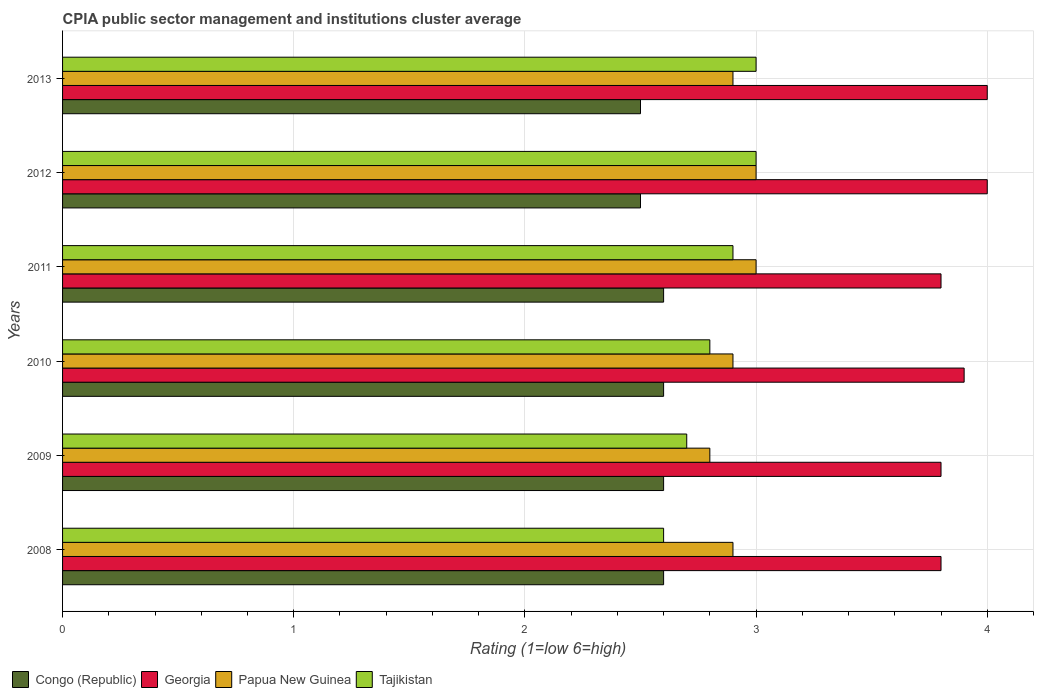How many different coloured bars are there?
Offer a very short reply. 4. How many groups of bars are there?
Your answer should be compact. 6. Are the number of bars per tick equal to the number of legend labels?
Keep it short and to the point. Yes. How many bars are there on the 2nd tick from the bottom?
Offer a very short reply. 4. Across all years, what is the maximum CPIA rating in Tajikistan?
Your response must be concise. 3. Across all years, what is the minimum CPIA rating in Papua New Guinea?
Make the answer very short. 2.8. What is the total CPIA rating in Georgia in the graph?
Your answer should be very brief. 23.3. What is the difference between the CPIA rating in Papua New Guinea in 2008 and that in 2010?
Provide a succinct answer. 0. What is the average CPIA rating in Georgia per year?
Give a very brief answer. 3.88. In how many years, is the CPIA rating in Georgia greater than 0.6000000000000001 ?
Make the answer very short. 6. Is the difference between the CPIA rating in Georgia in 2011 and 2012 greater than the difference between the CPIA rating in Tajikistan in 2011 and 2012?
Ensure brevity in your answer.  No. What is the difference between the highest and the second highest CPIA rating in Papua New Guinea?
Make the answer very short. 0. What is the difference between the highest and the lowest CPIA rating in Georgia?
Provide a short and direct response. 0.2. In how many years, is the CPIA rating in Tajikistan greater than the average CPIA rating in Tajikistan taken over all years?
Provide a succinct answer. 3. Is the sum of the CPIA rating in Congo (Republic) in 2009 and 2011 greater than the maximum CPIA rating in Tajikistan across all years?
Give a very brief answer. Yes. What does the 4th bar from the top in 2009 represents?
Your answer should be compact. Congo (Republic). What does the 4th bar from the bottom in 2012 represents?
Provide a succinct answer. Tajikistan. Is it the case that in every year, the sum of the CPIA rating in Papua New Guinea and CPIA rating in Tajikistan is greater than the CPIA rating in Georgia?
Your answer should be very brief. Yes. How many bars are there?
Keep it short and to the point. 24. Are all the bars in the graph horizontal?
Ensure brevity in your answer.  Yes. How many years are there in the graph?
Keep it short and to the point. 6. What is the difference between two consecutive major ticks on the X-axis?
Offer a terse response. 1. Does the graph contain grids?
Your answer should be compact. Yes. How many legend labels are there?
Provide a succinct answer. 4. How are the legend labels stacked?
Offer a terse response. Horizontal. What is the title of the graph?
Provide a succinct answer. CPIA public sector management and institutions cluster average. Does "Malta" appear as one of the legend labels in the graph?
Your response must be concise. No. What is the label or title of the X-axis?
Offer a terse response. Rating (1=low 6=high). What is the Rating (1=low 6=high) in Congo (Republic) in 2009?
Ensure brevity in your answer.  2.6. What is the Rating (1=low 6=high) in Congo (Republic) in 2010?
Your answer should be very brief. 2.6. What is the Rating (1=low 6=high) in Tajikistan in 2010?
Your answer should be very brief. 2.8. What is the Rating (1=low 6=high) in Congo (Republic) in 2011?
Your answer should be compact. 2.6. What is the Rating (1=low 6=high) of Tajikistan in 2011?
Your response must be concise. 2.9. What is the Rating (1=low 6=high) of Georgia in 2012?
Your response must be concise. 4. What is the Rating (1=low 6=high) of Congo (Republic) in 2013?
Offer a very short reply. 2.5. What is the Rating (1=low 6=high) of Georgia in 2013?
Provide a succinct answer. 4. What is the Rating (1=low 6=high) in Papua New Guinea in 2013?
Offer a terse response. 2.9. Across all years, what is the maximum Rating (1=low 6=high) in Georgia?
Give a very brief answer. 4. Across all years, what is the maximum Rating (1=low 6=high) of Tajikistan?
Your answer should be compact. 3. Across all years, what is the minimum Rating (1=low 6=high) of Georgia?
Offer a very short reply. 3.8. Across all years, what is the minimum Rating (1=low 6=high) of Papua New Guinea?
Ensure brevity in your answer.  2.8. What is the total Rating (1=low 6=high) of Congo (Republic) in the graph?
Offer a terse response. 15.4. What is the total Rating (1=low 6=high) of Georgia in the graph?
Ensure brevity in your answer.  23.3. What is the total Rating (1=low 6=high) in Tajikistan in the graph?
Provide a short and direct response. 17. What is the difference between the Rating (1=low 6=high) of Congo (Republic) in 2008 and that in 2009?
Keep it short and to the point. 0. What is the difference between the Rating (1=low 6=high) in Tajikistan in 2008 and that in 2010?
Make the answer very short. -0.2. What is the difference between the Rating (1=low 6=high) of Georgia in 2008 and that in 2011?
Ensure brevity in your answer.  0. What is the difference between the Rating (1=low 6=high) of Papua New Guinea in 2008 and that in 2011?
Make the answer very short. -0.1. What is the difference between the Rating (1=low 6=high) in Tajikistan in 2008 and that in 2011?
Make the answer very short. -0.3. What is the difference between the Rating (1=low 6=high) in Congo (Republic) in 2008 and that in 2012?
Keep it short and to the point. 0.1. What is the difference between the Rating (1=low 6=high) of Georgia in 2008 and that in 2012?
Provide a succinct answer. -0.2. What is the difference between the Rating (1=low 6=high) in Papua New Guinea in 2008 and that in 2013?
Provide a succinct answer. 0. What is the difference between the Rating (1=low 6=high) of Tajikistan in 2009 and that in 2010?
Provide a short and direct response. -0.1. What is the difference between the Rating (1=low 6=high) of Congo (Republic) in 2009 and that in 2011?
Ensure brevity in your answer.  0. What is the difference between the Rating (1=low 6=high) in Tajikistan in 2009 and that in 2011?
Offer a very short reply. -0.2. What is the difference between the Rating (1=low 6=high) in Congo (Republic) in 2009 and that in 2012?
Your response must be concise. 0.1. What is the difference between the Rating (1=low 6=high) in Georgia in 2009 and that in 2013?
Your answer should be very brief. -0.2. What is the difference between the Rating (1=low 6=high) in Papua New Guinea in 2009 and that in 2013?
Offer a terse response. -0.1. What is the difference between the Rating (1=low 6=high) in Tajikistan in 2010 and that in 2011?
Your response must be concise. -0.1. What is the difference between the Rating (1=low 6=high) in Congo (Republic) in 2010 and that in 2012?
Your answer should be very brief. 0.1. What is the difference between the Rating (1=low 6=high) in Tajikistan in 2010 and that in 2012?
Offer a very short reply. -0.2. What is the difference between the Rating (1=low 6=high) of Congo (Republic) in 2010 and that in 2013?
Make the answer very short. 0.1. What is the difference between the Rating (1=low 6=high) in Georgia in 2010 and that in 2013?
Your response must be concise. -0.1. What is the difference between the Rating (1=low 6=high) in Tajikistan in 2010 and that in 2013?
Provide a short and direct response. -0.2. What is the difference between the Rating (1=low 6=high) in Georgia in 2011 and that in 2012?
Offer a terse response. -0.2. What is the difference between the Rating (1=low 6=high) of Papua New Guinea in 2011 and that in 2012?
Keep it short and to the point. 0. What is the difference between the Rating (1=low 6=high) in Tajikistan in 2011 and that in 2012?
Your answer should be compact. -0.1. What is the difference between the Rating (1=low 6=high) of Congo (Republic) in 2011 and that in 2013?
Make the answer very short. 0.1. What is the difference between the Rating (1=low 6=high) of Congo (Republic) in 2012 and that in 2013?
Your response must be concise. 0. What is the difference between the Rating (1=low 6=high) of Tajikistan in 2012 and that in 2013?
Provide a succinct answer. 0. What is the difference between the Rating (1=low 6=high) in Papua New Guinea in 2008 and the Rating (1=low 6=high) in Tajikistan in 2009?
Offer a very short reply. 0.2. What is the difference between the Rating (1=low 6=high) of Congo (Republic) in 2008 and the Rating (1=low 6=high) of Georgia in 2010?
Your answer should be compact. -1.3. What is the difference between the Rating (1=low 6=high) of Georgia in 2008 and the Rating (1=low 6=high) of Tajikistan in 2010?
Provide a short and direct response. 1. What is the difference between the Rating (1=low 6=high) of Papua New Guinea in 2008 and the Rating (1=low 6=high) of Tajikistan in 2010?
Your response must be concise. 0.1. What is the difference between the Rating (1=low 6=high) in Congo (Republic) in 2008 and the Rating (1=low 6=high) in Georgia in 2011?
Make the answer very short. -1.2. What is the difference between the Rating (1=low 6=high) of Congo (Republic) in 2008 and the Rating (1=low 6=high) of Tajikistan in 2011?
Offer a very short reply. -0.3. What is the difference between the Rating (1=low 6=high) of Georgia in 2008 and the Rating (1=low 6=high) of Papua New Guinea in 2011?
Offer a terse response. 0.8. What is the difference between the Rating (1=low 6=high) of Congo (Republic) in 2008 and the Rating (1=low 6=high) of Papua New Guinea in 2012?
Keep it short and to the point. -0.4. What is the difference between the Rating (1=low 6=high) in Georgia in 2008 and the Rating (1=low 6=high) in Papua New Guinea in 2012?
Your answer should be very brief. 0.8. What is the difference between the Rating (1=low 6=high) in Papua New Guinea in 2008 and the Rating (1=low 6=high) in Tajikistan in 2012?
Your response must be concise. -0.1. What is the difference between the Rating (1=low 6=high) in Congo (Republic) in 2008 and the Rating (1=low 6=high) in Georgia in 2013?
Provide a succinct answer. -1.4. What is the difference between the Rating (1=low 6=high) in Georgia in 2008 and the Rating (1=low 6=high) in Papua New Guinea in 2013?
Provide a succinct answer. 0.9. What is the difference between the Rating (1=low 6=high) in Congo (Republic) in 2009 and the Rating (1=low 6=high) in Georgia in 2010?
Your answer should be very brief. -1.3. What is the difference between the Rating (1=low 6=high) in Georgia in 2009 and the Rating (1=low 6=high) in Papua New Guinea in 2011?
Provide a succinct answer. 0.8. What is the difference between the Rating (1=low 6=high) in Congo (Republic) in 2009 and the Rating (1=low 6=high) in Georgia in 2012?
Your response must be concise. -1.4. What is the difference between the Rating (1=low 6=high) of Congo (Republic) in 2009 and the Rating (1=low 6=high) of Papua New Guinea in 2012?
Provide a short and direct response. -0.4. What is the difference between the Rating (1=low 6=high) in Georgia in 2009 and the Rating (1=low 6=high) in Papua New Guinea in 2012?
Offer a terse response. 0.8. What is the difference between the Rating (1=low 6=high) of Papua New Guinea in 2009 and the Rating (1=low 6=high) of Tajikistan in 2012?
Offer a very short reply. -0.2. What is the difference between the Rating (1=low 6=high) of Congo (Republic) in 2009 and the Rating (1=low 6=high) of Papua New Guinea in 2013?
Keep it short and to the point. -0.3. What is the difference between the Rating (1=low 6=high) of Congo (Republic) in 2009 and the Rating (1=low 6=high) of Tajikistan in 2013?
Ensure brevity in your answer.  -0.4. What is the difference between the Rating (1=low 6=high) in Georgia in 2009 and the Rating (1=low 6=high) in Tajikistan in 2013?
Your response must be concise. 0.8. What is the difference between the Rating (1=low 6=high) in Papua New Guinea in 2009 and the Rating (1=low 6=high) in Tajikistan in 2013?
Your answer should be compact. -0.2. What is the difference between the Rating (1=low 6=high) in Congo (Republic) in 2010 and the Rating (1=low 6=high) in Georgia in 2011?
Your answer should be very brief. -1.2. What is the difference between the Rating (1=low 6=high) of Congo (Republic) in 2010 and the Rating (1=low 6=high) of Papua New Guinea in 2011?
Ensure brevity in your answer.  -0.4. What is the difference between the Rating (1=low 6=high) of Congo (Republic) in 2010 and the Rating (1=low 6=high) of Tajikistan in 2011?
Make the answer very short. -0.3. What is the difference between the Rating (1=low 6=high) in Papua New Guinea in 2010 and the Rating (1=low 6=high) in Tajikistan in 2011?
Provide a short and direct response. 0. What is the difference between the Rating (1=low 6=high) in Papua New Guinea in 2010 and the Rating (1=low 6=high) in Tajikistan in 2012?
Keep it short and to the point. -0.1. What is the difference between the Rating (1=low 6=high) in Congo (Republic) in 2010 and the Rating (1=low 6=high) in Tajikistan in 2013?
Offer a very short reply. -0.4. What is the difference between the Rating (1=low 6=high) of Georgia in 2010 and the Rating (1=low 6=high) of Tajikistan in 2013?
Give a very brief answer. 0.9. What is the difference between the Rating (1=low 6=high) in Papua New Guinea in 2010 and the Rating (1=low 6=high) in Tajikistan in 2013?
Provide a short and direct response. -0.1. What is the difference between the Rating (1=low 6=high) in Congo (Republic) in 2011 and the Rating (1=low 6=high) in Papua New Guinea in 2012?
Ensure brevity in your answer.  -0.4. What is the difference between the Rating (1=low 6=high) in Congo (Republic) in 2011 and the Rating (1=low 6=high) in Tajikistan in 2012?
Provide a short and direct response. -0.4. What is the difference between the Rating (1=low 6=high) of Georgia in 2011 and the Rating (1=low 6=high) of Tajikistan in 2012?
Give a very brief answer. 0.8. What is the difference between the Rating (1=low 6=high) of Papua New Guinea in 2011 and the Rating (1=low 6=high) of Tajikistan in 2012?
Offer a terse response. 0. What is the difference between the Rating (1=low 6=high) of Congo (Republic) in 2011 and the Rating (1=low 6=high) of Georgia in 2013?
Your response must be concise. -1.4. What is the difference between the Rating (1=low 6=high) in Congo (Republic) in 2011 and the Rating (1=low 6=high) in Tajikistan in 2013?
Keep it short and to the point. -0.4. What is the difference between the Rating (1=low 6=high) of Georgia in 2011 and the Rating (1=low 6=high) of Papua New Guinea in 2013?
Keep it short and to the point. 0.9. What is the difference between the Rating (1=low 6=high) in Georgia in 2011 and the Rating (1=low 6=high) in Tajikistan in 2013?
Keep it short and to the point. 0.8. What is the difference between the Rating (1=low 6=high) of Papua New Guinea in 2011 and the Rating (1=low 6=high) of Tajikistan in 2013?
Keep it short and to the point. 0. What is the difference between the Rating (1=low 6=high) in Congo (Republic) in 2012 and the Rating (1=low 6=high) in Georgia in 2013?
Your response must be concise. -1.5. What is the difference between the Rating (1=low 6=high) in Georgia in 2012 and the Rating (1=low 6=high) in Tajikistan in 2013?
Your answer should be very brief. 1. What is the average Rating (1=low 6=high) in Congo (Republic) per year?
Provide a succinct answer. 2.57. What is the average Rating (1=low 6=high) of Georgia per year?
Keep it short and to the point. 3.88. What is the average Rating (1=low 6=high) of Papua New Guinea per year?
Keep it short and to the point. 2.92. What is the average Rating (1=low 6=high) in Tajikistan per year?
Keep it short and to the point. 2.83. In the year 2008, what is the difference between the Rating (1=low 6=high) of Congo (Republic) and Rating (1=low 6=high) of Tajikistan?
Offer a very short reply. 0. In the year 2008, what is the difference between the Rating (1=low 6=high) of Georgia and Rating (1=low 6=high) of Papua New Guinea?
Provide a succinct answer. 0.9. In the year 2008, what is the difference between the Rating (1=low 6=high) in Papua New Guinea and Rating (1=low 6=high) in Tajikistan?
Your response must be concise. 0.3. In the year 2009, what is the difference between the Rating (1=low 6=high) of Congo (Republic) and Rating (1=low 6=high) of Papua New Guinea?
Offer a terse response. -0.2. In the year 2009, what is the difference between the Rating (1=low 6=high) of Georgia and Rating (1=low 6=high) of Papua New Guinea?
Make the answer very short. 1. In the year 2009, what is the difference between the Rating (1=low 6=high) of Georgia and Rating (1=low 6=high) of Tajikistan?
Offer a terse response. 1.1. In the year 2009, what is the difference between the Rating (1=low 6=high) of Papua New Guinea and Rating (1=low 6=high) of Tajikistan?
Offer a terse response. 0.1. In the year 2010, what is the difference between the Rating (1=low 6=high) in Congo (Republic) and Rating (1=low 6=high) in Papua New Guinea?
Provide a succinct answer. -0.3. In the year 2011, what is the difference between the Rating (1=low 6=high) in Congo (Republic) and Rating (1=low 6=high) in Georgia?
Your response must be concise. -1.2. In the year 2011, what is the difference between the Rating (1=low 6=high) in Papua New Guinea and Rating (1=low 6=high) in Tajikistan?
Provide a short and direct response. 0.1. In the year 2012, what is the difference between the Rating (1=low 6=high) in Congo (Republic) and Rating (1=low 6=high) in Papua New Guinea?
Your answer should be very brief. -0.5. In the year 2012, what is the difference between the Rating (1=low 6=high) in Papua New Guinea and Rating (1=low 6=high) in Tajikistan?
Offer a very short reply. 0. In the year 2013, what is the difference between the Rating (1=low 6=high) of Congo (Republic) and Rating (1=low 6=high) of Papua New Guinea?
Provide a short and direct response. -0.4. In the year 2013, what is the difference between the Rating (1=low 6=high) in Georgia and Rating (1=low 6=high) in Papua New Guinea?
Offer a terse response. 1.1. What is the ratio of the Rating (1=low 6=high) in Georgia in 2008 to that in 2009?
Your response must be concise. 1. What is the ratio of the Rating (1=low 6=high) of Papua New Guinea in 2008 to that in 2009?
Ensure brevity in your answer.  1.04. What is the ratio of the Rating (1=low 6=high) in Congo (Republic) in 2008 to that in 2010?
Provide a short and direct response. 1. What is the ratio of the Rating (1=low 6=high) in Georgia in 2008 to that in 2010?
Your answer should be compact. 0.97. What is the ratio of the Rating (1=low 6=high) in Papua New Guinea in 2008 to that in 2010?
Make the answer very short. 1. What is the ratio of the Rating (1=low 6=high) in Georgia in 2008 to that in 2011?
Ensure brevity in your answer.  1. What is the ratio of the Rating (1=low 6=high) in Papua New Guinea in 2008 to that in 2011?
Your answer should be compact. 0.97. What is the ratio of the Rating (1=low 6=high) in Tajikistan in 2008 to that in 2011?
Give a very brief answer. 0.9. What is the ratio of the Rating (1=low 6=high) in Papua New Guinea in 2008 to that in 2012?
Offer a very short reply. 0.97. What is the ratio of the Rating (1=low 6=high) in Tajikistan in 2008 to that in 2012?
Ensure brevity in your answer.  0.87. What is the ratio of the Rating (1=low 6=high) in Congo (Republic) in 2008 to that in 2013?
Give a very brief answer. 1.04. What is the ratio of the Rating (1=low 6=high) of Georgia in 2008 to that in 2013?
Your response must be concise. 0.95. What is the ratio of the Rating (1=low 6=high) of Tajikistan in 2008 to that in 2013?
Offer a very short reply. 0.87. What is the ratio of the Rating (1=low 6=high) of Congo (Republic) in 2009 to that in 2010?
Give a very brief answer. 1. What is the ratio of the Rating (1=low 6=high) of Georgia in 2009 to that in 2010?
Provide a succinct answer. 0.97. What is the ratio of the Rating (1=low 6=high) of Papua New Guinea in 2009 to that in 2010?
Keep it short and to the point. 0.97. What is the ratio of the Rating (1=low 6=high) in Tajikistan in 2009 to that in 2010?
Give a very brief answer. 0.96. What is the ratio of the Rating (1=low 6=high) of Georgia in 2009 to that in 2011?
Offer a very short reply. 1. What is the ratio of the Rating (1=low 6=high) of Papua New Guinea in 2009 to that in 2011?
Make the answer very short. 0.93. What is the ratio of the Rating (1=low 6=high) of Tajikistan in 2009 to that in 2012?
Your answer should be compact. 0.9. What is the ratio of the Rating (1=low 6=high) of Congo (Republic) in 2009 to that in 2013?
Give a very brief answer. 1.04. What is the ratio of the Rating (1=low 6=high) of Papua New Guinea in 2009 to that in 2013?
Provide a short and direct response. 0.97. What is the ratio of the Rating (1=low 6=high) of Congo (Republic) in 2010 to that in 2011?
Provide a short and direct response. 1. What is the ratio of the Rating (1=low 6=high) of Georgia in 2010 to that in 2011?
Make the answer very short. 1.03. What is the ratio of the Rating (1=low 6=high) in Papua New Guinea in 2010 to that in 2011?
Give a very brief answer. 0.97. What is the ratio of the Rating (1=low 6=high) of Tajikistan in 2010 to that in 2011?
Ensure brevity in your answer.  0.97. What is the ratio of the Rating (1=low 6=high) in Papua New Guinea in 2010 to that in 2012?
Give a very brief answer. 0.97. What is the ratio of the Rating (1=low 6=high) in Tajikistan in 2010 to that in 2012?
Offer a very short reply. 0.93. What is the ratio of the Rating (1=low 6=high) of Congo (Republic) in 2010 to that in 2013?
Your answer should be compact. 1.04. What is the ratio of the Rating (1=low 6=high) of Georgia in 2010 to that in 2013?
Make the answer very short. 0.97. What is the ratio of the Rating (1=low 6=high) of Papua New Guinea in 2010 to that in 2013?
Offer a terse response. 1. What is the ratio of the Rating (1=low 6=high) in Papua New Guinea in 2011 to that in 2012?
Make the answer very short. 1. What is the ratio of the Rating (1=low 6=high) of Tajikistan in 2011 to that in 2012?
Provide a succinct answer. 0.97. What is the ratio of the Rating (1=low 6=high) of Georgia in 2011 to that in 2013?
Provide a short and direct response. 0.95. What is the ratio of the Rating (1=low 6=high) in Papua New Guinea in 2011 to that in 2013?
Keep it short and to the point. 1.03. What is the ratio of the Rating (1=low 6=high) in Tajikistan in 2011 to that in 2013?
Make the answer very short. 0.97. What is the ratio of the Rating (1=low 6=high) in Congo (Republic) in 2012 to that in 2013?
Ensure brevity in your answer.  1. What is the ratio of the Rating (1=low 6=high) of Papua New Guinea in 2012 to that in 2013?
Your response must be concise. 1.03. What is the ratio of the Rating (1=low 6=high) of Tajikistan in 2012 to that in 2013?
Your answer should be very brief. 1. What is the difference between the highest and the second highest Rating (1=low 6=high) of Georgia?
Provide a succinct answer. 0. What is the difference between the highest and the second highest Rating (1=low 6=high) of Papua New Guinea?
Your response must be concise. 0. What is the difference between the highest and the second highest Rating (1=low 6=high) in Tajikistan?
Your answer should be very brief. 0. What is the difference between the highest and the lowest Rating (1=low 6=high) of Congo (Republic)?
Give a very brief answer. 0.1. What is the difference between the highest and the lowest Rating (1=low 6=high) in Georgia?
Your response must be concise. 0.2. What is the difference between the highest and the lowest Rating (1=low 6=high) in Tajikistan?
Give a very brief answer. 0.4. 